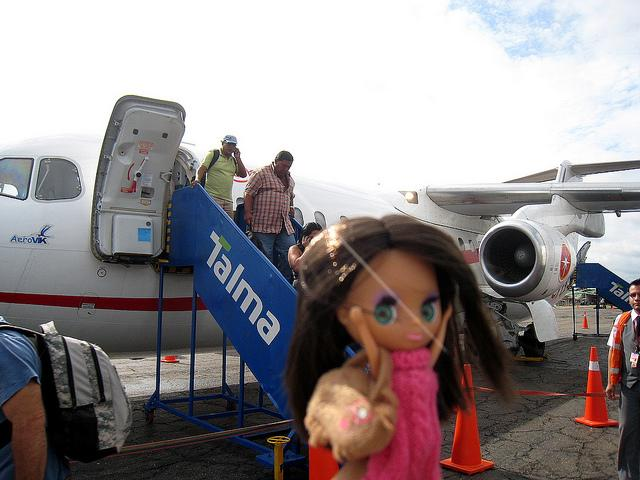What type of doll is in the front of the picture? plastic 